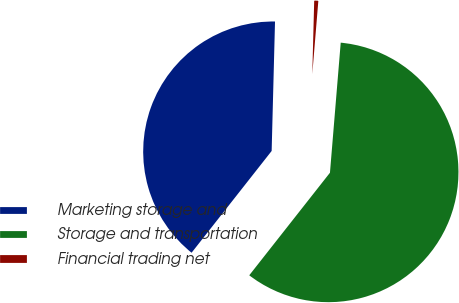Convert chart to OTSL. <chart><loc_0><loc_0><loc_500><loc_500><pie_chart><fcel>Marketing storage and<fcel>Storage and transportation<fcel>Financial trading net<nl><fcel>39.8%<fcel>59.29%<fcel>0.9%<nl></chart> 